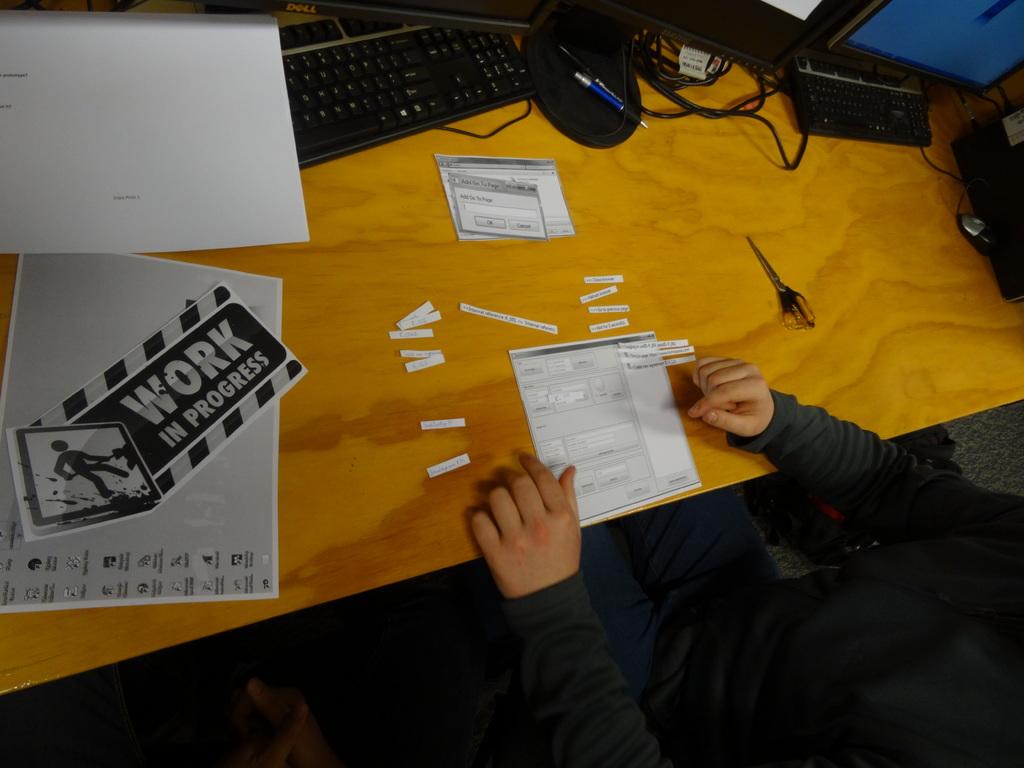What is the sign used for?
Provide a succinct answer. Work in progress. What is in progress?
Keep it short and to the point. Work. 